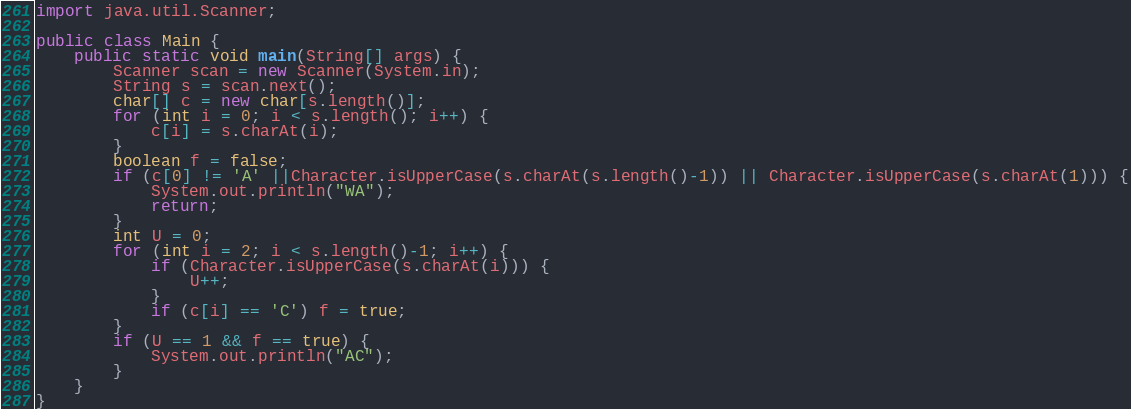Convert code to text. <code><loc_0><loc_0><loc_500><loc_500><_Java_>import java.util.Scanner;

public class Main {	
	public static void main(String[] args) {
		Scanner scan = new Scanner(System.in);
		String s = scan.next();
		char[] c = new char[s.length()];
		for (int i = 0; i < s.length(); i++) {
			c[i] = s.charAt(i);
		}
		boolean f = false;
		if (c[0] != 'A' ||Character.isUpperCase(s.charAt(s.length()-1)) || Character.isUpperCase(s.charAt(1))) {
			System.out.println("WA");
			return;
		}
		int U = 0;
		for (int i = 2; i < s.length()-1; i++) {
			if (Character.isUpperCase(s.charAt(i))) {
				U++;
			}
			if (c[i] == 'C') f = true;
		}
		if (U == 1 && f == true) {
			System.out.println("AC");
		}
	}
}
</code> 